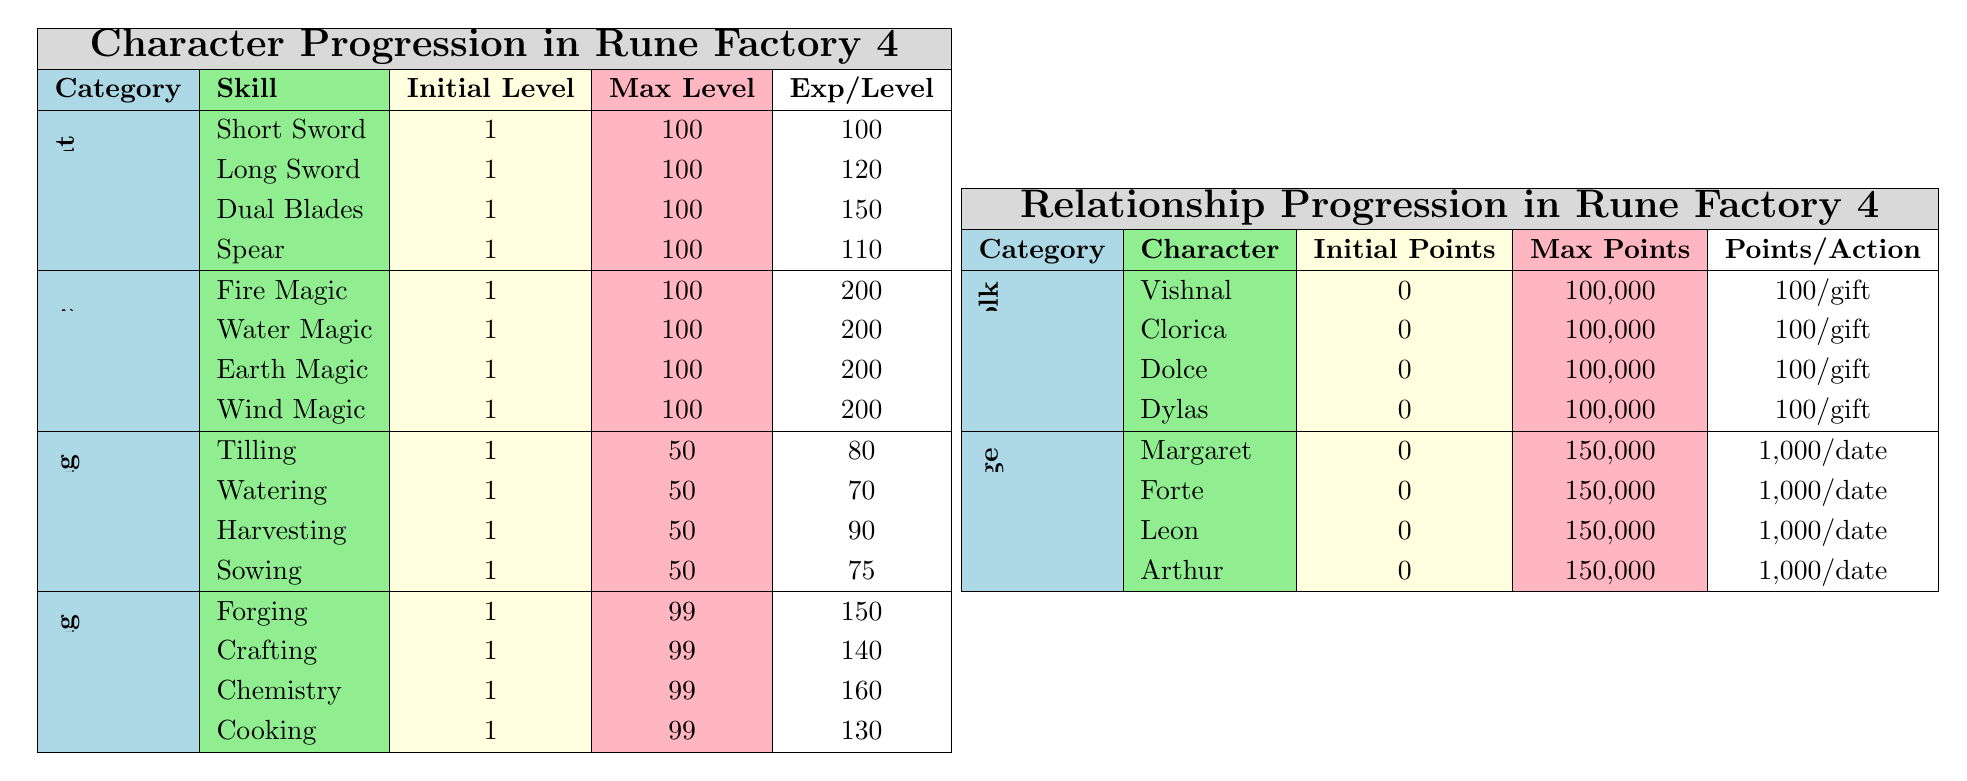What is the maximum level for the Short Sword skill? The table indicates that the "Max Level" for the "Short Sword" skill is 100.
Answer: 100 How many experience points are needed to reach the maximum level for the Dual Blades skill? The "Experience Per Level" for "Dual Blades" is 150, and the max level is 100, so the total experience needed is 150 * (100 - 1) = 150 * 99 = 14850.
Answer: 14850 Which magic skill requires the highest experience points per level? All magic skills (Fire, Water, Earth, Wind) require 200 experience points per level; hence, none require more than this.
Answer: 200 What is the total number of experience points needed for all farming skills to reach their maximum levels? The max levels are: Tilling (50), Watering (50), Harvesting (50), Sowing (50). Experience points needed: (80 * 49) + (70 * 49) + (90 * 49) + (75 * 49) = 3920 + 3430 + 4410 + 3675 = 15435.
Answer: 15435 Is the maximum friendship points for any townsfolk character equal to 100,000? Yes, the table shows that all townsfolk characters (Vishnal, Clorica, Dolce, Dylas) have a maximum friendship points of 100,000.
Answer: Yes Which crafting skill has the highest experience points required to level up? The experience points required for each crafting skill are Forging (150), Crafting (140), Chemistry (160), and Cooking (130). The highest is for Chemistry at 160.
Answer: 160 What is the total number of points required for Margaret to go from initial to maximum love points? Margaret's initial love points are 0 and max love points are 150,000, hence total points required = 150,000 - 0 = 150,000.
Answer: 150000 If an action gives 100 points to all townsfolk, how many times would an action need to be performed to max out friendship with Dylas? Dylas needs 100,000 friendship points, and each gift gives 100 points; thus, 100,000 / 100 = 1,000 actions are needed.
Answer: 1000 How does the initial level of all magic skills compare to the initial level of all combat skills? Both combat skills (Short Sword, Long Sword, etc.) and magic skills all start at an initial level of 1.
Answer: They are equal What is the average experience points per level of all combat skills? The experience points for combat skills are as follows: Short Sword (100), Long Sword (120), Dual Blades (150), Spear (110). The average = (100 + 120 + 150 + 110) / 4 = 480 / 4 = 120.
Answer: 120 